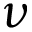Convert formula to latex. <formula><loc_0><loc_0><loc_500><loc_500>\nu</formula> 